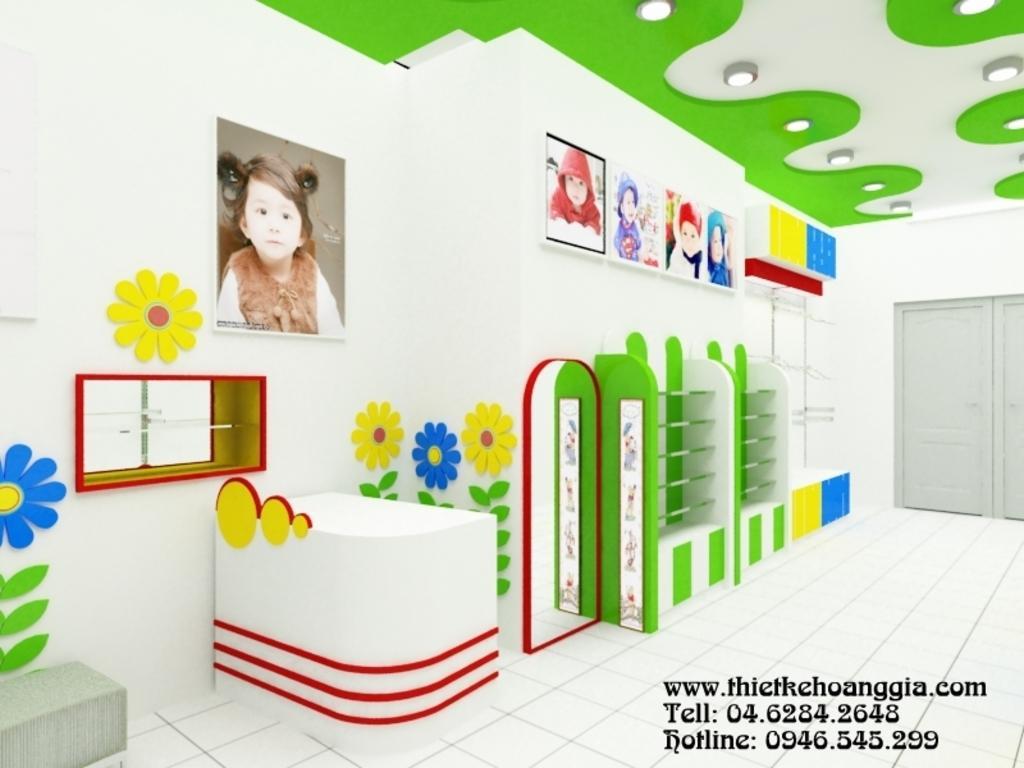Can you describe this image briefly? This image is taken in the room. In this image there are stands and we can see a mirror. There is a table. On the left there is a window. On the right we can see a door. In the background there is a wall and we can see frames placed on the wall. At the top there are lights. 